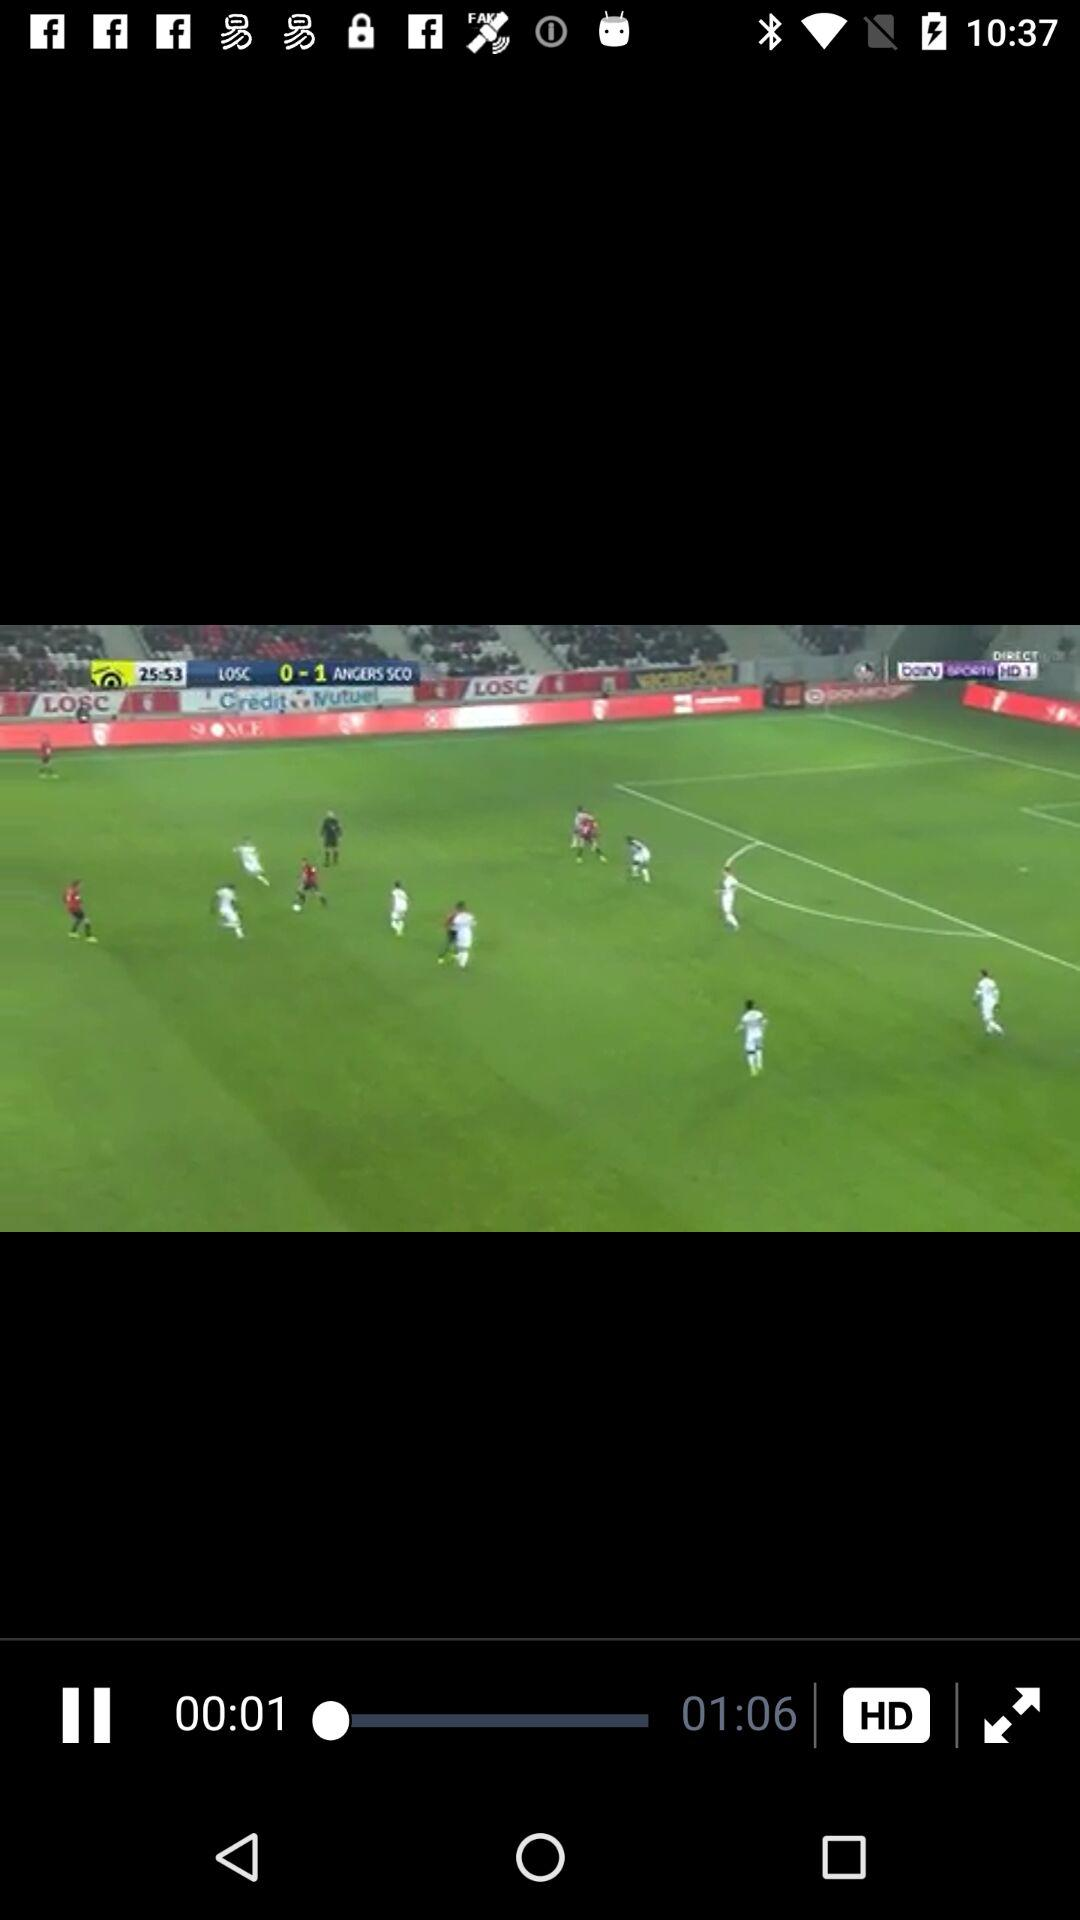How many seconds are between the two timestamps on the screen?
Answer the question using a single word or phrase. 65 